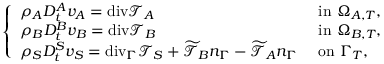Convert formula to latex. <formula><loc_0><loc_0><loc_500><loc_500>\left \{ \begin{array} { l l } { \rho _ { A } D _ { t } ^ { A } v _ { A } = { d i v } \mathcal { T } _ { A } } & { i n \Omega _ { A , T } , } \\ { \rho _ { B } D _ { t } ^ { B } v _ { B } = { d i v } \mathcal { T } _ { B } } & { i n \Omega _ { B , T } , } \\ { \rho _ { S } D _ { t } ^ { S } v _ { S } = { d i v } _ { \Gamma } \mathcal { T } _ { S } + \widetilde { \mathcal { T } } _ { B } n _ { \Gamma } - \widetilde { \mathcal { T } } _ { A } n _ { \Gamma } } & { o n \Gamma _ { T } , } \end{array}</formula> 